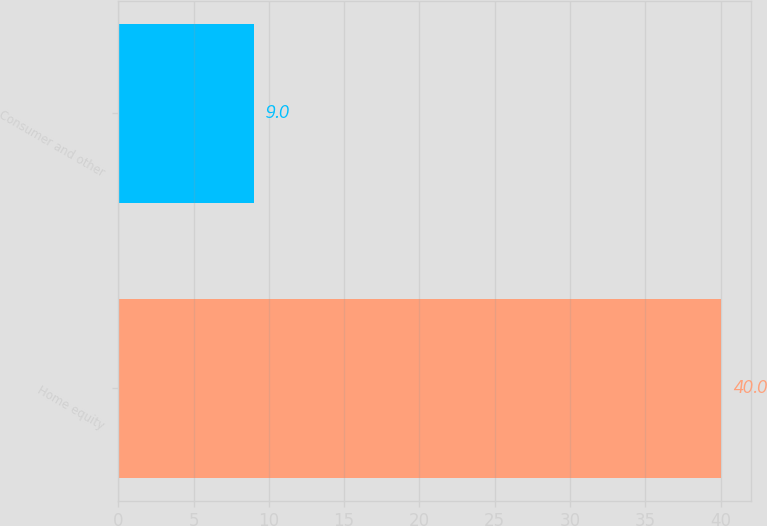Convert chart. <chart><loc_0><loc_0><loc_500><loc_500><bar_chart><fcel>Home equity<fcel>Consumer and other<nl><fcel>40<fcel>9<nl></chart> 